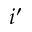Convert formula to latex. <formula><loc_0><loc_0><loc_500><loc_500>i ^ { \prime }</formula> 